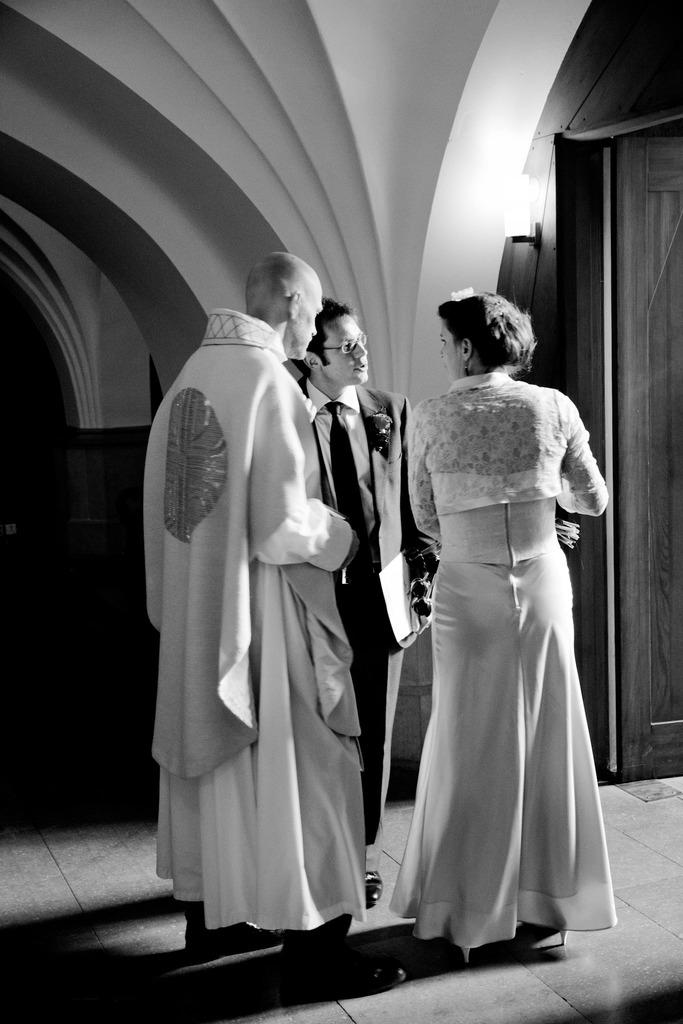How many people are present in the image? There are three people in the image: one woman and two men. What is one of the men holding? One of the men is holding a file. What can be seen in front of the people in the image? There is a light in front of the people in the image. What type of photography is used for the image? The image is black and white photography. What type of grape is being used as a prop in the image? There is no grape present in the image. What season is depicted in the image? The image does not depict a specific season, as it is black and white photography. Can you see a robin in the image? There is no robin present in the image. 